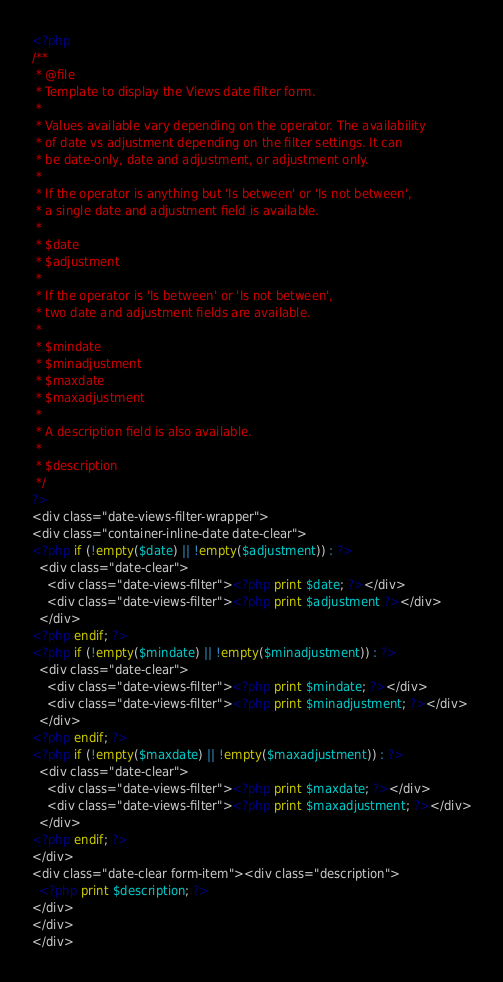Convert code to text. <code><loc_0><loc_0><loc_500><loc_500><_PHP_><?php
/**
 * @file
 * Template to display the Views date filter form.
 *
 * Values available vary depending on the operator. The availability
 * of date vs adjustment depending on the filter settings. It can
 * be date-only, date and adjustment, or adjustment only.
 *
 * If the operator is anything but 'Is between' or 'Is not between',
 * a single date and adjustment field is available.
 *
 * $date
 * $adjustment
 *
 * If the operator is 'Is between' or 'Is not between',
 * two date and adjustment fields are available.
 *
 * $mindate
 * $minadjustment
 * $maxdate
 * $maxadjustment
 *
 * A description field is also available.
 *
 * $description
 */
?>
<div class="date-views-filter-wrapper">
<div class="container-inline-date date-clear">
<?php if (!empty($date) || !empty($adjustment)) : ?>
  <div class="date-clear">
    <div class="date-views-filter"><?php print $date; ?></div>
    <div class="date-views-filter"><?php print $adjustment ?></div>
  </div>
<?php endif; ?>
<?php if (!empty($mindate) || !empty($minadjustment)) : ?>
  <div class="date-clear">
    <div class="date-views-filter"><?php print $mindate; ?></div>
    <div class="date-views-filter"><?php print $minadjustment; ?></div>
  </div>
<?php endif; ?>
<?php if (!empty($maxdate) || !empty($maxadjustment)) : ?>
  <div class="date-clear">
    <div class="date-views-filter"><?php print $maxdate; ?></div>
    <div class="date-views-filter"><?php print $maxadjustment; ?></div>
  </div>
<?php endif; ?>
</div>
<div class="date-clear form-item"><div class="description">
  <?php print $description; ?>
</div>
</div>
</div></code> 